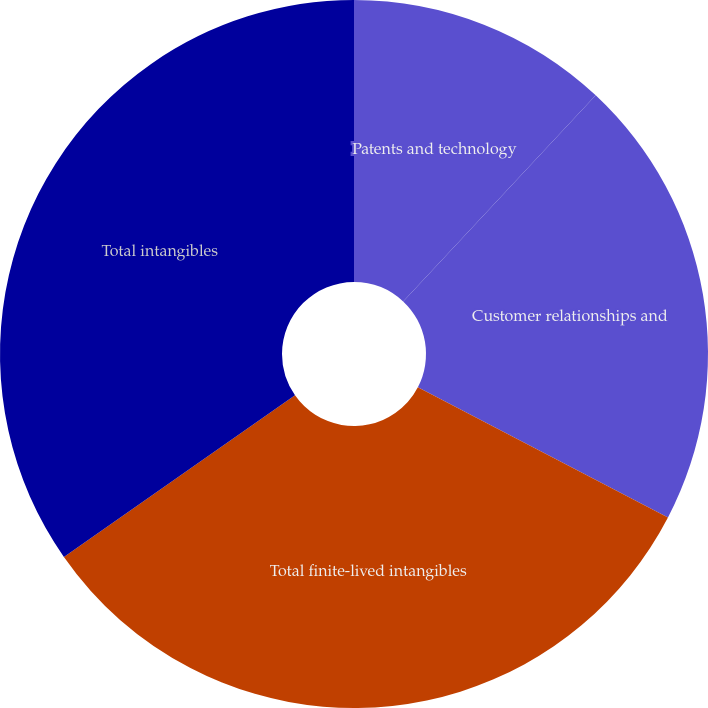Convert chart to OTSL. <chart><loc_0><loc_0><loc_500><loc_500><pie_chart><fcel>Patents and technology<fcel>Customer relationships and<fcel>Total finite-lived intangibles<fcel>Total intangibles<nl><fcel>11.96%<fcel>20.68%<fcel>32.64%<fcel>34.71%<nl></chart> 